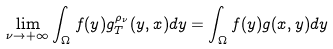Convert formula to latex. <formula><loc_0><loc_0><loc_500><loc_500>\lim _ { \nu \to + \infty } \int _ { \Omega } f ( y ) g ^ { \rho _ { \nu } } _ { T } ( y , x ) d y = \int _ { \Omega } f ( y ) g ( x , y ) d y</formula> 